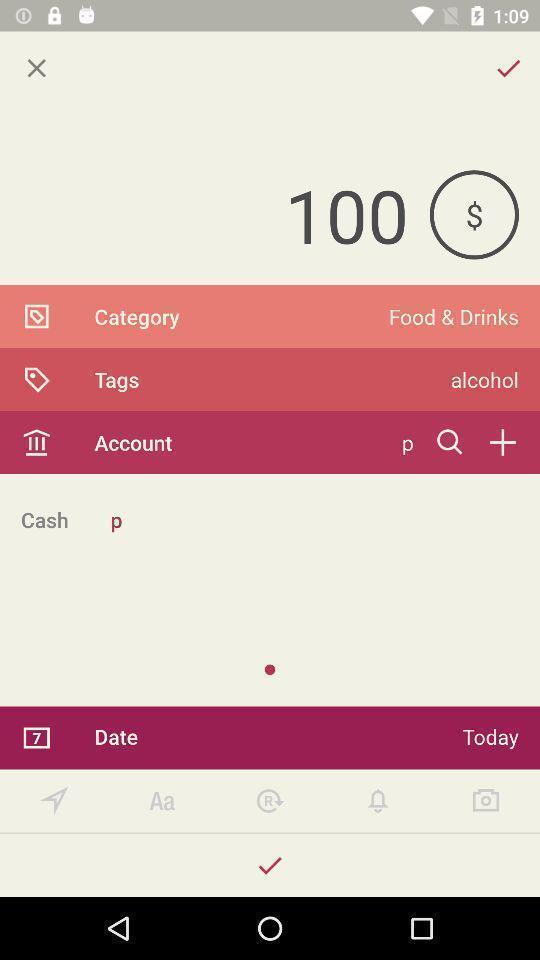Summarize the information in this screenshot. Payment screen. 